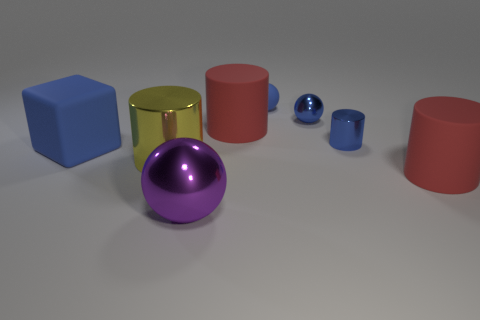Subtract 1 cylinders. How many cylinders are left? 3 Add 1 large blue things. How many objects exist? 9 Subtract all cubes. How many objects are left? 7 Subtract all tiny blue metal balls. Subtract all rubber objects. How many objects are left? 3 Add 1 tiny things. How many tiny things are left? 4 Add 7 blue matte cubes. How many blue matte cubes exist? 8 Subtract 0 red cubes. How many objects are left? 8 